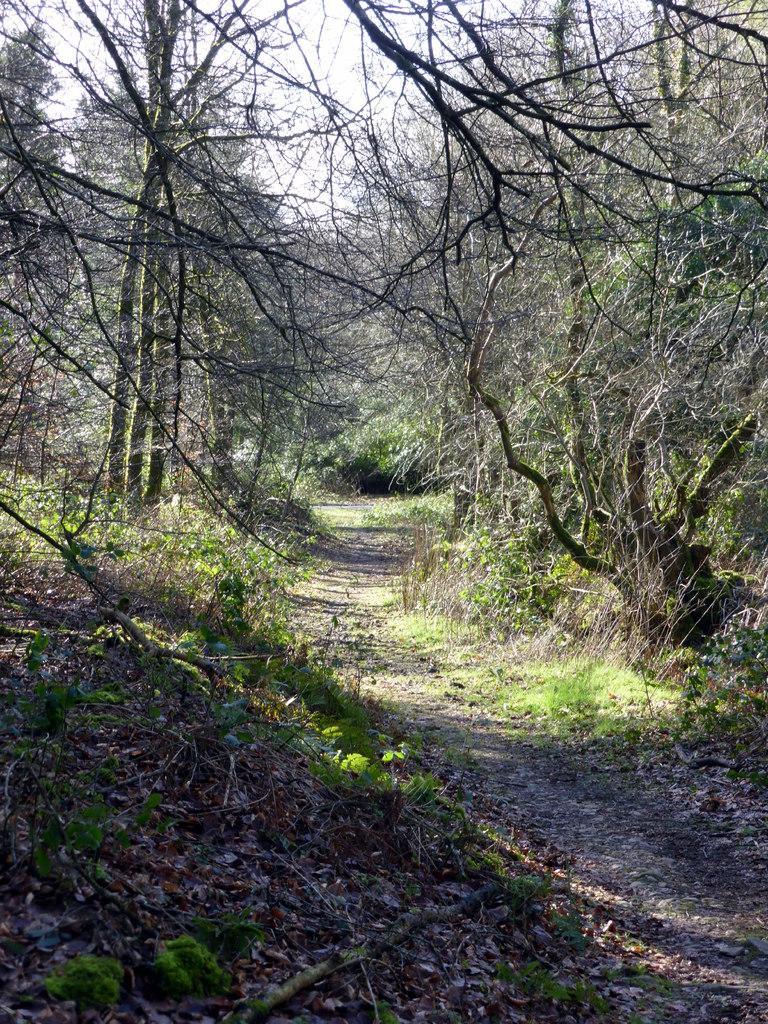How would you summarize this image in a sentence or two? In this image there are trees and grass on the surface, in the middle of the image there is a pathway. 